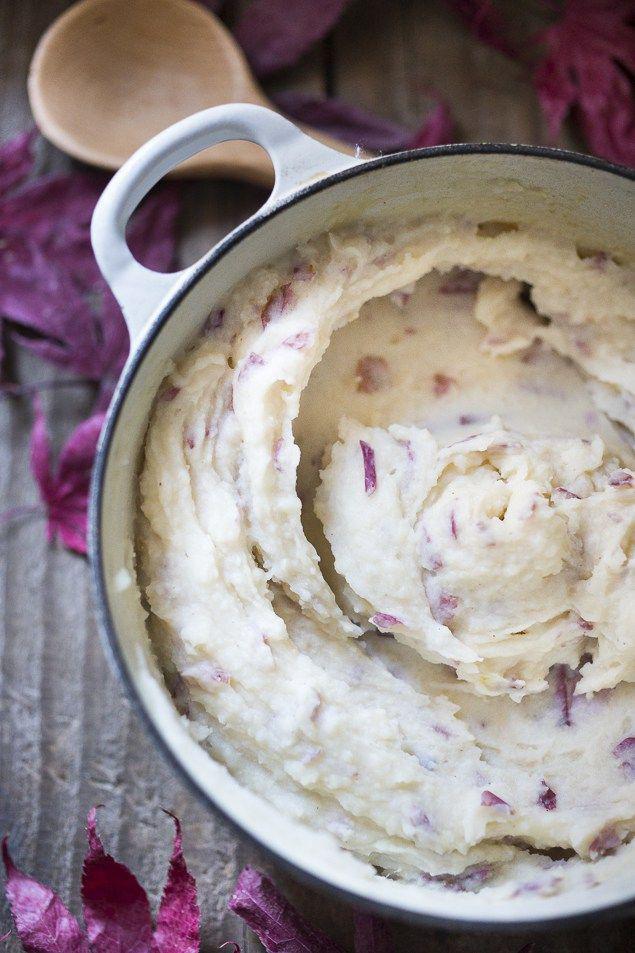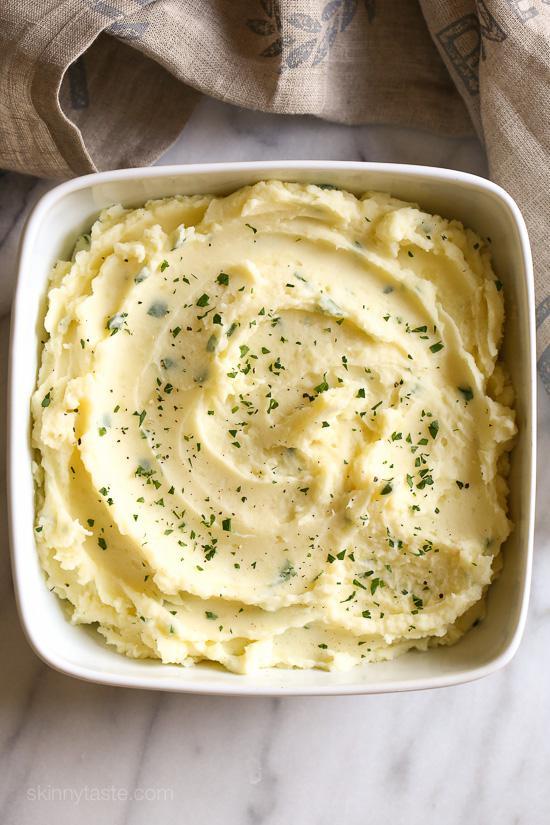The first image is the image on the left, the second image is the image on the right. For the images shown, is this caption "The dish in the image on the left has a spoon in it." true? Answer yes or no. No. The first image is the image on the left, the second image is the image on the right. Assess this claim about the two images: "Each image shows a spoon with a bowl of mashed potatoes, and the spoons are made of the same type of material.". Correct or not? Answer yes or no. No. 